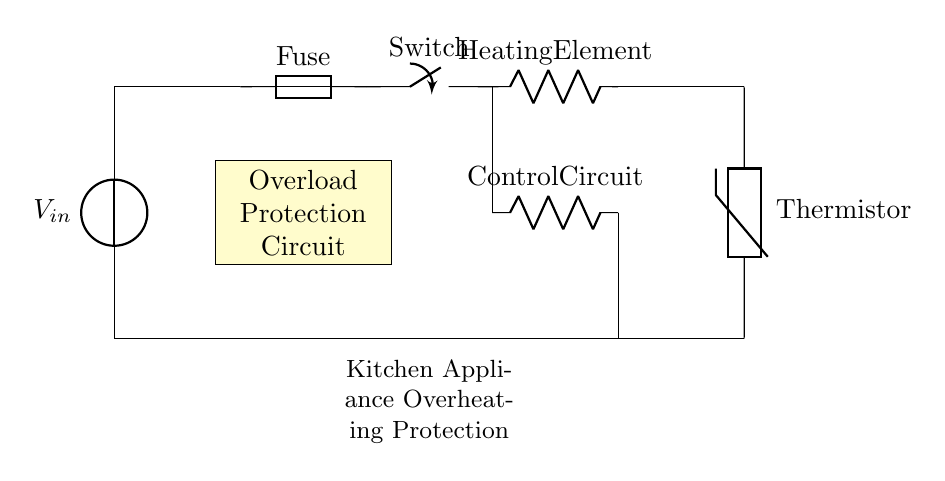What is the first component in the circuit? The first component in the circuit is the voltage source indicated by the notation V_in. This can be found at the top of the diagram, which represents the source of electrical energy for the circuit.
Answer: Voltage source What type of protection does this circuit provide? The circuit provides overload protection, specifically designed to prevent overheating in kitchen appliances. This is indicated by the label on the circuit diagram marked "Overload Protection Circuit."
Answer: Overload protection What does the fuse component do in this circuit? The fuse acts as a safety device that interrupts the electrical flow if the current exceeds a certain limit, thereby protecting the circuit from overload and potential damage. The diagram labels it as "Fuse" next to the component symbol.
Answer: Interrupts current How is the control circuit connected in relation to the heating element? The control circuit is connected in parallel to the heating element as shown by the vertical lines drawn leading from the switch to the control circuit, and then to the heating element below it. This parallel arrangement allows the control circuit to regulate the operation of the heating element without affecting the full supply of voltage.
Answer: In parallel What activates the overload protection in this circuit? The overload protection is activated by overheating, which is sensed by the thermistor in the circuit. The presence of the thermistor, placed below the heating element, implies it measures temperature changes and triggers the protection mechanism when overheating is detected.
Answer: Thermistor What happens when the current exceeds the rated limit in this circuit? When the current exceeds the rated limit, the fuse will blow, which breaks the circuit and stops the flow of electricity to prevent overheating and potential fire hazards. This is a critical safety feature included in the design, represented by the fuse labeled in the diagram.
Answer: Fuse blows 